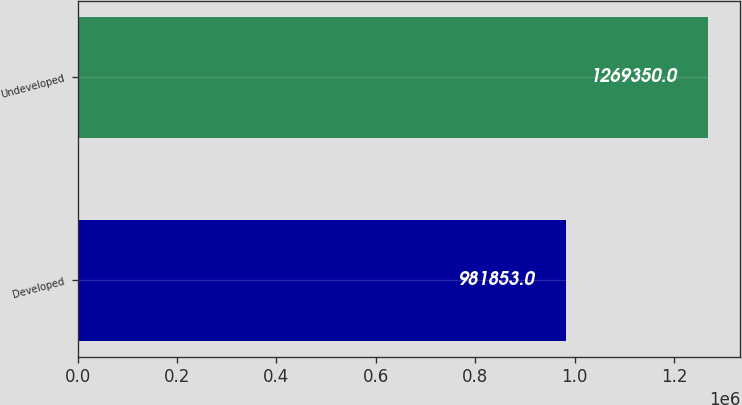Convert chart. <chart><loc_0><loc_0><loc_500><loc_500><bar_chart><fcel>Developed<fcel>Undeveloped<nl><fcel>981853<fcel>1.26935e+06<nl></chart> 